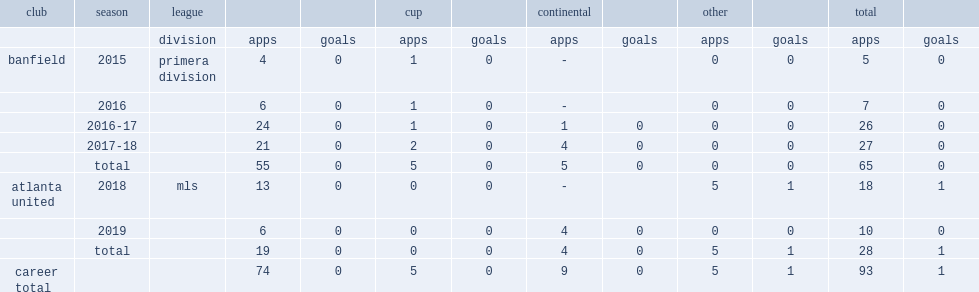Which league did remedi's career start in 2015 side banfield? Primera division. 